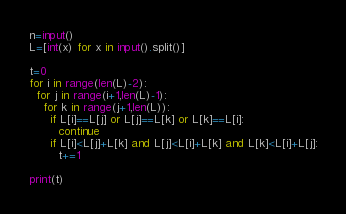Convert code to text. <code><loc_0><loc_0><loc_500><loc_500><_Python_>n=input()
L=[int(x) for x in input().split()]

t=0
for i in range(len(L)-2):
  for j in range(i+1,len(L)-1):
    for k in range(j+1,len(L)):
      if L[i]==L[j] or L[j]==L[k] or L[k]==L[i]:
        continue
      if L[i]<L[j]+L[k] and L[j]<L[i]+L[k] and L[k]<L[i]+L[j]:
        t+=1

print(t)
</code> 